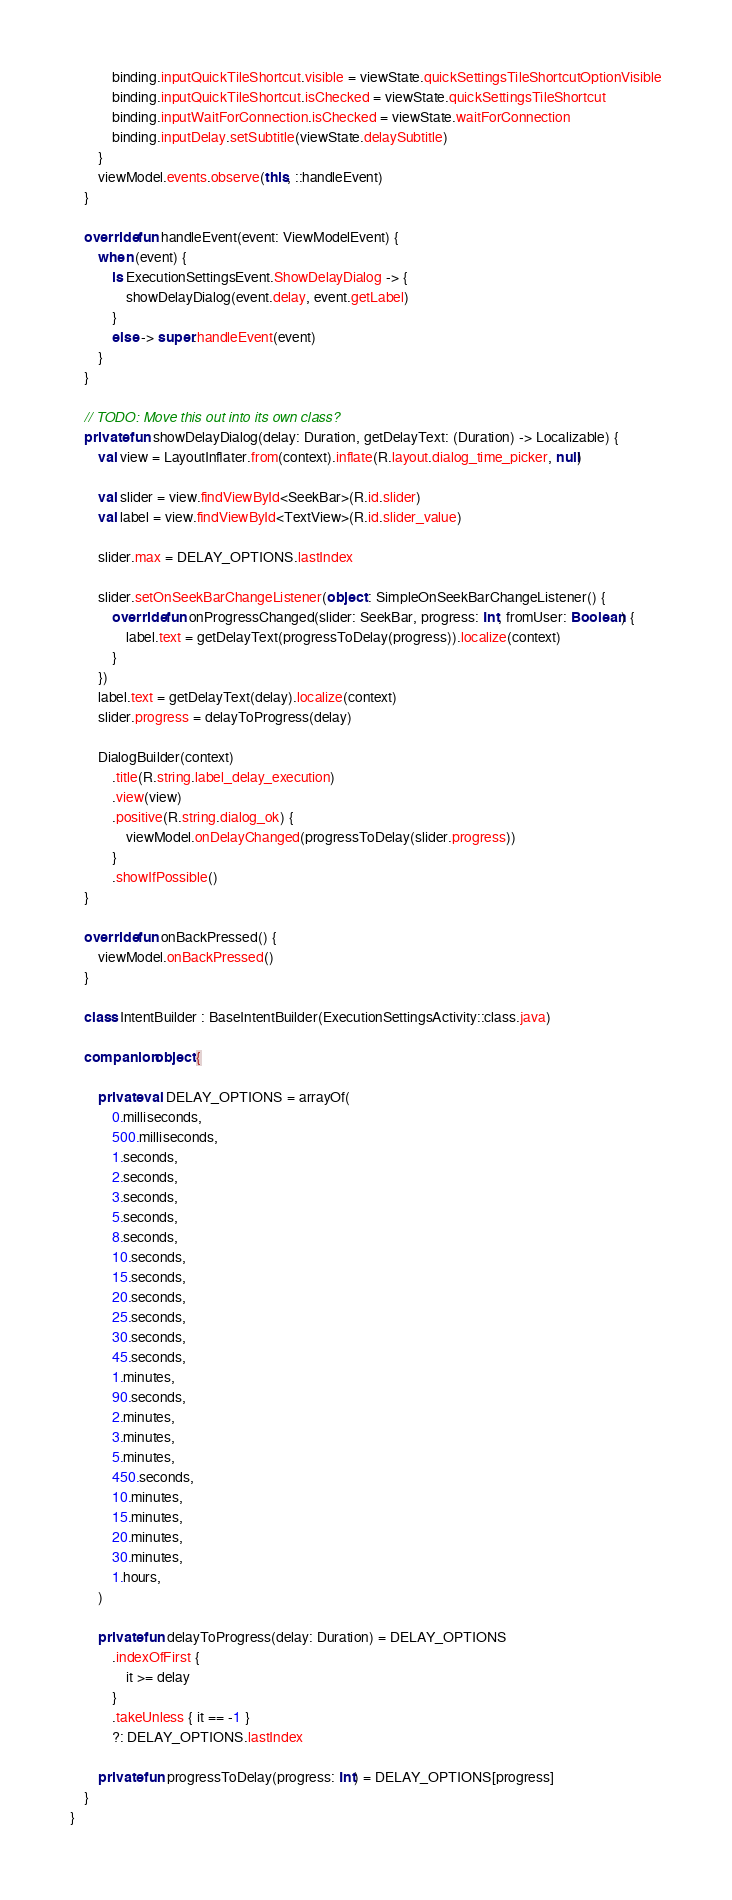Convert code to text. <code><loc_0><loc_0><loc_500><loc_500><_Kotlin_>            binding.inputQuickTileShortcut.visible = viewState.quickSettingsTileShortcutOptionVisible
            binding.inputQuickTileShortcut.isChecked = viewState.quickSettingsTileShortcut
            binding.inputWaitForConnection.isChecked = viewState.waitForConnection
            binding.inputDelay.setSubtitle(viewState.delaySubtitle)
        }
        viewModel.events.observe(this, ::handleEvent)
    }

    override fun handleEvent(event: ViewModelEvent) {
        when (event) {
            is ExecutionSettingsEvent.ShowDelayDialog -> {
                showDelayDialog(event.delay, event.getLabel)
            }
            else -> super.handleEvent(event)
        }
    }

    // TODO: Move this out into its own class?
    private fun showDelayDialog(delay: Duration, getDelayText: (Duration) -> Localizable) {
        val view = LayoutInflater.from(context).inflate(R.layout.dialog_time_picker, null)

        val slider = view.findViewById<SeekBar>(R.id.slider)
        val label = view.findViewById<TextView>(R.id.slider_value)

        slider.max = DELAY_OPTIONS.lastIndex

        slider.setOnSeekBarChangeListener(object : SimpleOnSeekBarChangeListener() {
            override fun onProgressChanged(slider: SeekBar, progress: Int, fromUser: Boolean) {
                label.text = getDelayText(progressToDelay(progress)).localize(context)
            }
        })
        label.text = getDelayText(delay).localize(context)
        slider.progress = delayToProgress(delay)

        DialogBuilder(context)
            .title(R.string.label_delay_execution)
            .view(view)
            .positive(R.string.dialog_ok) {
                viewModel.onDelayChanged(progressToDelay(slider.progress))
            }
            .showIfPossible()
    }

    override fun onBackPressed() {
        viewModel.onBackPressed()
    }

    class IntentBuilder : BaseIntentBuilder(ExecutionSettingsActivity::class.java)

    companion object {

        private val DELAY_OPTIONS = arrayOf(
            0.milliseconds,
            500.milliseconds,
            1.seconds,
            2.seconds,
            3.seconds,
            5.seconds,
            8.seconds,
            10.seconds,
            15.seconds,
            20.seconds,
            25.seconds,
            30.seconds,
            45.seconds,
            1.minutes,
            90.seconds,
            2.minutes,
            3.minutes,
            5.minutes,
            450.seconds,
            10.minutes,
            15.minutes,
            20.minutes,
            30.minutes,
            1.hours,
        )

        private fun delayToProgress(delay: Duration) = DELAY_OPTIONS
            .indexOfFirst {
                it >= delay
            }
            .takeUnless { it == -1 }
            ?: DELAY_OPTIONS.lastIndex

        private fun progressToDelay(progress: Int) = DELAY_OPTIONS[progress]
    }
}
</code> 